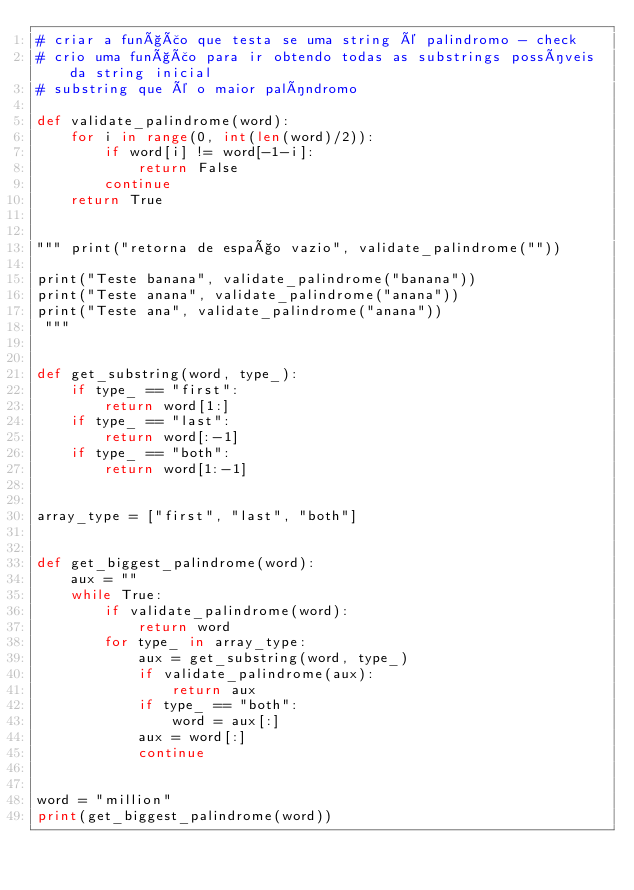<code> <loc_0><loc_0><loc_500><loc_500><_Python_># criar a função que testa se uma string é palindromo - check
# crio uma função para ir obtendo todas as substrings possíveis da string inicial
# substring que é o maior palíndromo

def validate_palindrome(word):
    for i in range(0, int(len(word)/2)):
        if word[i] != word[-1-i]:
            return False
        continue
    return True


""" print("retorna de espaço vazio", validate_palindrome(""))

print("Teste banana", validate_palindrome("banana"))
print("Teste anana", validate_palindrome("anana"))
print("Teste ana", validate_palindrome("anana"))
 """


def get_substring(word, type_):
    if type_ == "first":
        return word[1:]
    if type_ == "last":
        return word[:-1]
    if type_ == "both":
        return word[1:-1]


array_type = ["first", "last", "both"]


def get_biggest_palindrome(word):
    aux = ""
    while True:
        if validate_palindrome(word):
            return word
        for type_ in array_type:
            aux = get_substring(word, type_)
            if validate_palindrome(aux):
                return aux
            if type_ == "both":
                word = aux[:]
            aux = word[:]
            continue


word = "million"
print(get_biggest_palindrome(word))
</code> 